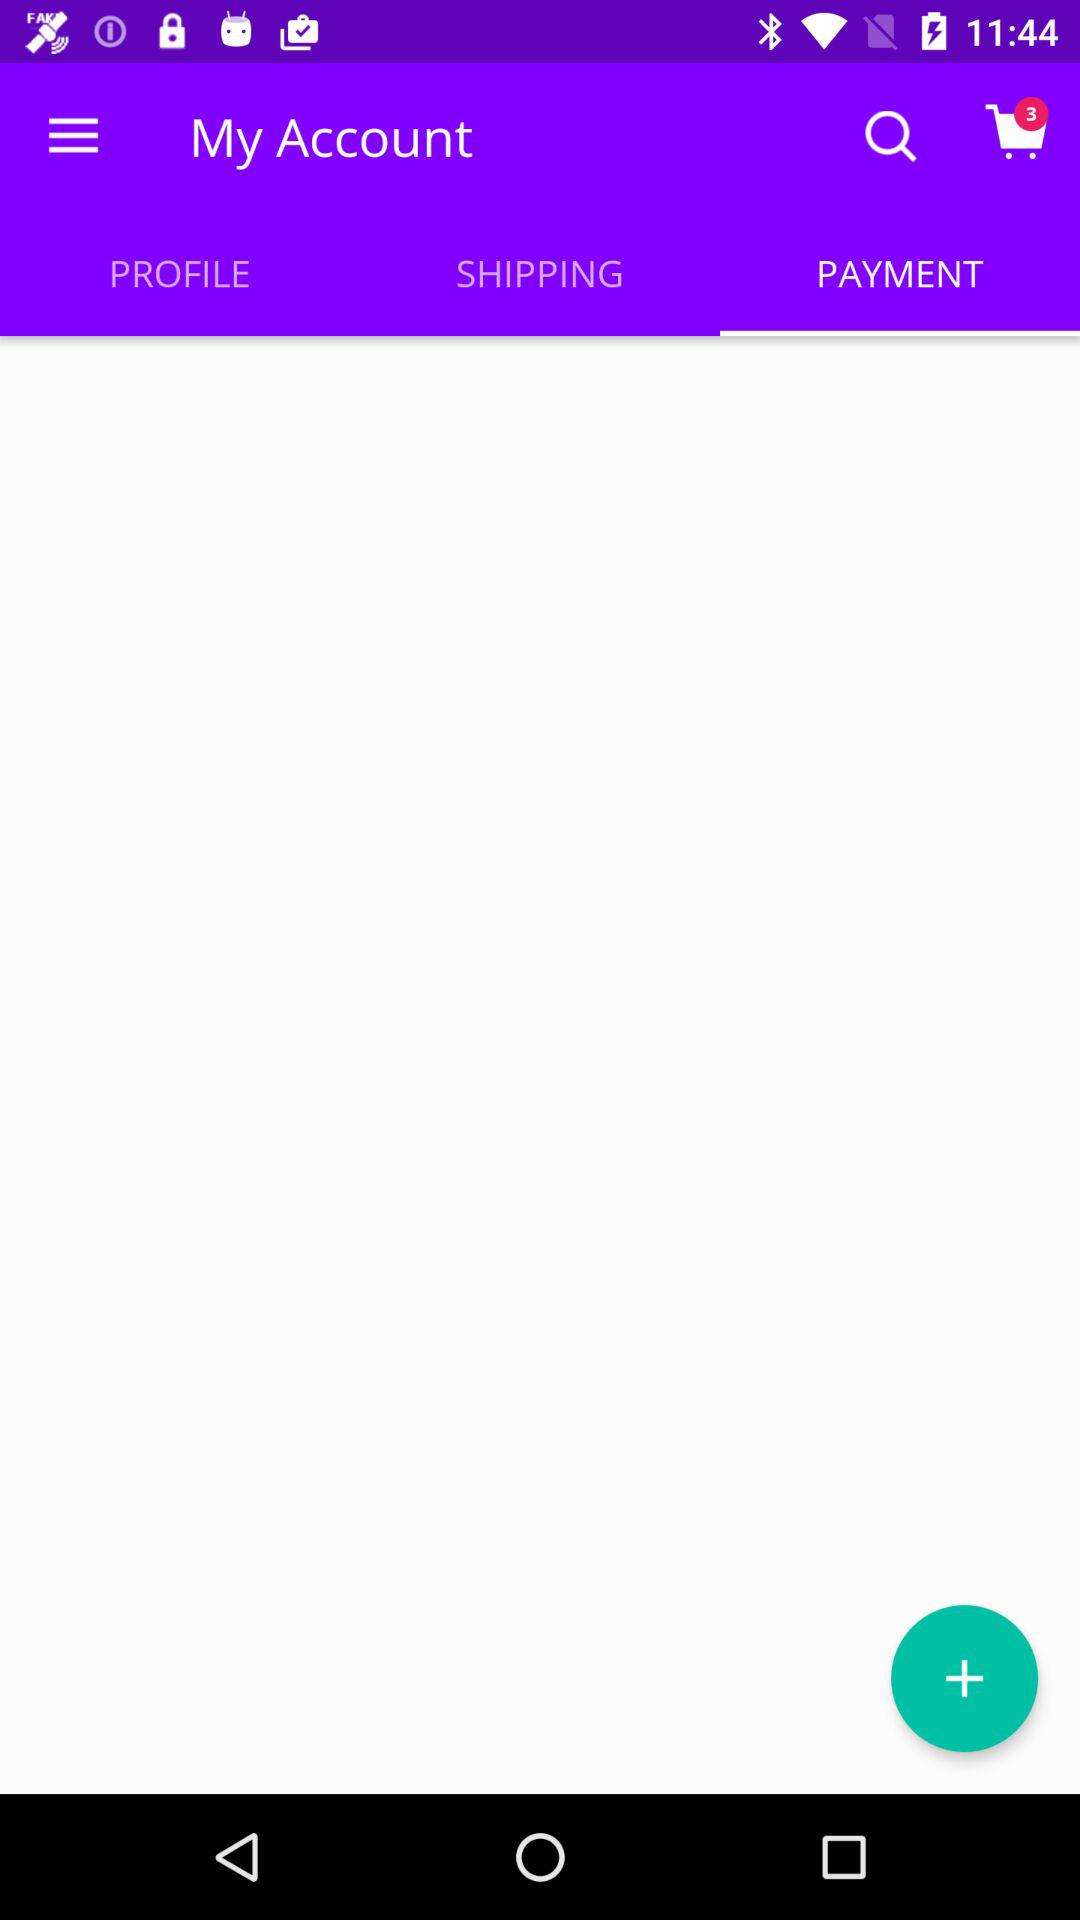Which tab is selected in my account? The selected tab is payment. 